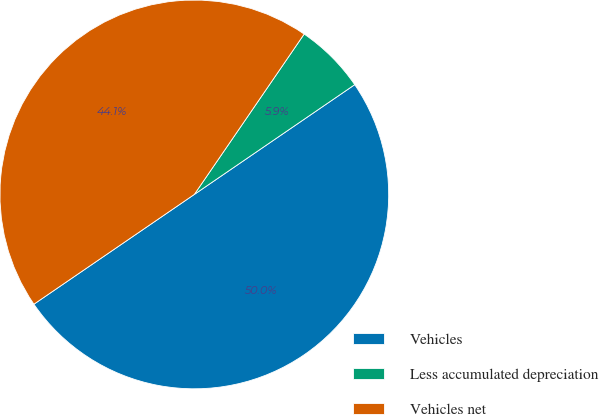Convert chart. <chart><loc_0><loc_0><loc_500><loc_500><pie_chart><fcel>Vehicles<fcel>Less accumulated depreciation<fcel>Vehicles net<nl><fcel>50.0%<fcel>5.89%<fcel>44.11%<nl></chart> 